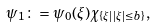Convert formula to latex. <formula><loc_0><loc_0><loc_500><loc_500>\psi _ { 1 } \colon = \psi _ { 0 } ( \xi ) \chi _ { \{ \xi | \, | \xi | \leq b \} } ,</formula> 